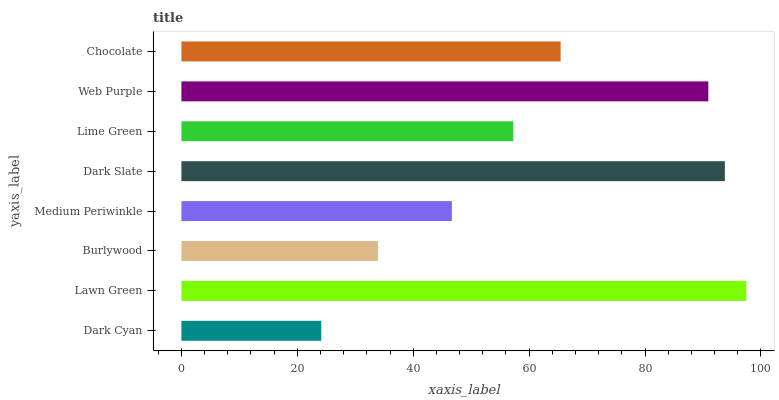Is Dark Cyan the minimum?
Answer yes or no. Yes. Is Lawn Green the maximum?
Answer yes or no. Yes. Is Burlywood the minimum?
Answer yes or no. No. Is Burlywood the maximum?
Answer yes or no. No. Is Lawn Green greater than Burlywood?
Answer yes or no. Yes. Is Burlywood less than Lawn Green?
Answer yes or no. Yes. Is Burlywood greater than Lawn Green?
Answer yes or no. No. Is Lawn Green less than Burlywood?
Answer yes or no. No. Is Chocolate the high median?
Answer yes or no. Yes. Is Lime Green the low median?
Answer yes or no. Yes. Is Medium Periwinkle the high median?
Answer yes or no. No. Is Dark Slate the low median?
Answer yes or no. No. 